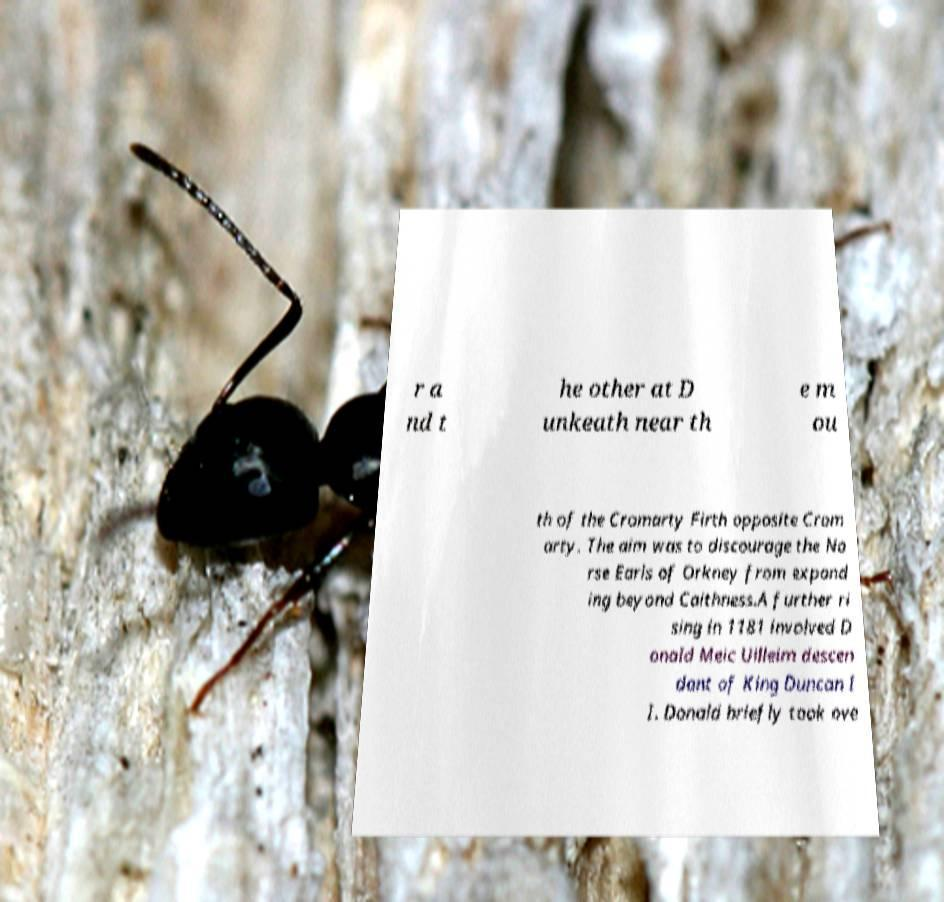Could you extract and type out the text from this image? r a nd t he other at D unkeath near th e m ou th of the Cromarty Firth opposite Crom arty. The aim was to discourage the No rse Earls of Orkney from expand ing beyond Caithness.A further ri sing in 1181 involved D onald Meic Uilleim descen dant of King Duncan I I. Donald briefly took ove 